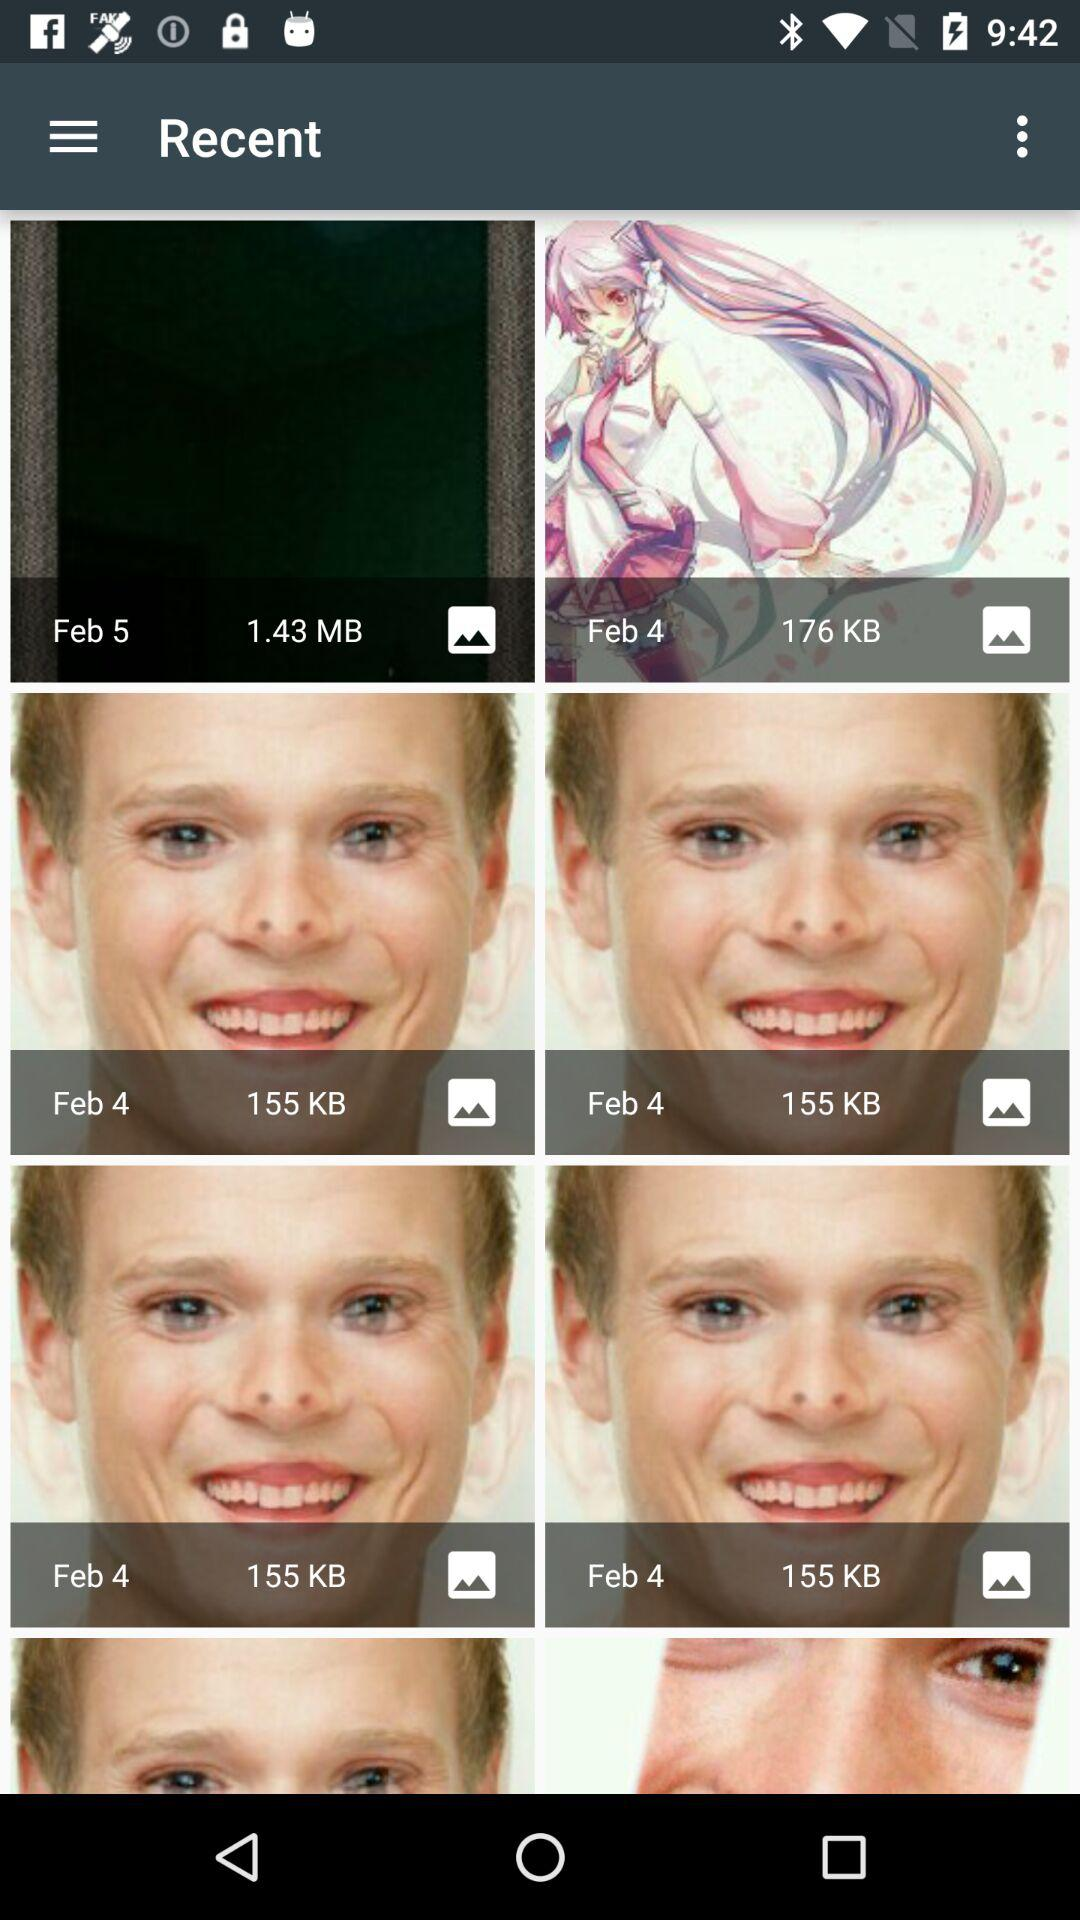Who posted the images?
When the provided information is insufficient, respond with <no answer>. <no answer> 